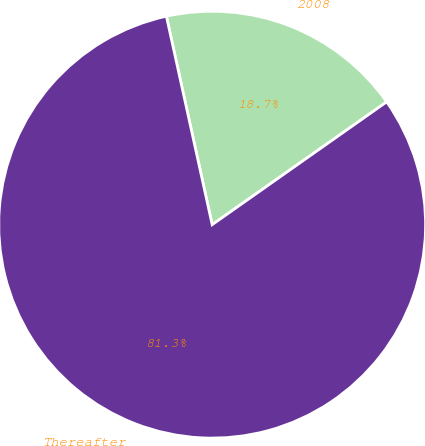Convert chart. <chart><loc_0><loc_0><loc_500><loc_500><pie_chart><fcel>2008<fcel>Thereafter<nl><fcel>18.68%<fcel>81.32%<nl></chart> 